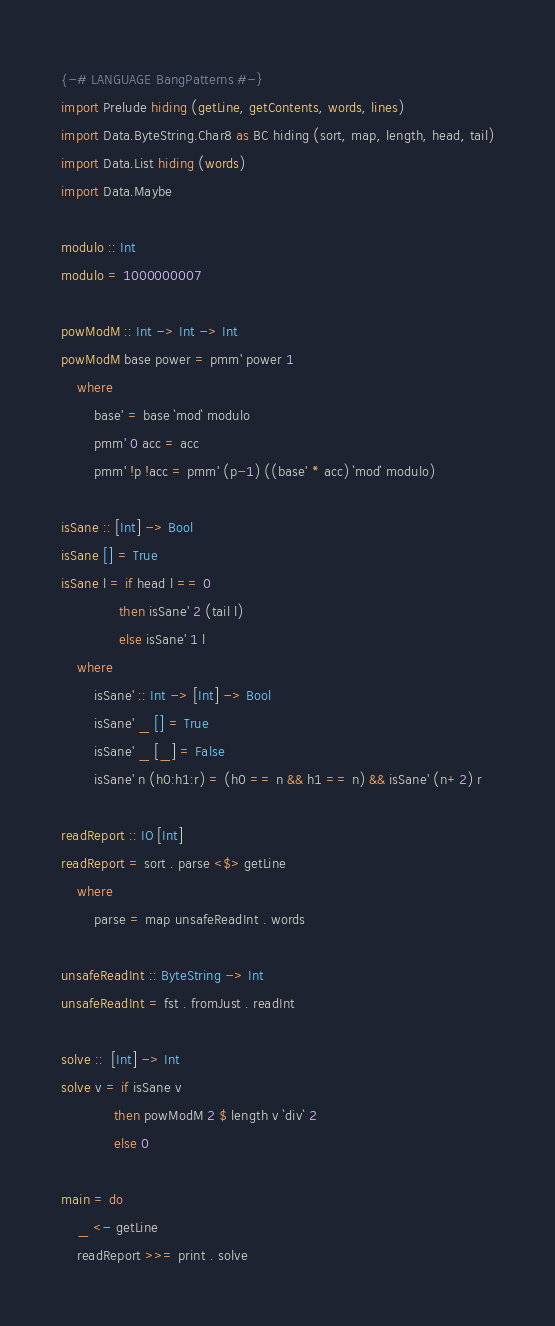<code> <loc_0><loc_0><loc_500><loc_500><_Haskell_>{-# LANGUAGE BangPatterns #-}
import Prelude hiding (getLine, getContents, words, lines)
import Data.ByteString.Char8 as BC hiding (sort, map, length, head, tail)
import Data.List hiding (words)
import Data.Maybe

modulo :: Int
modulo = 1000000007

powModM :: Int -> Int -> Int
powModM base power = pmm' power 1
    where
        base' = base `mod` modulo
        pmm' 0 acc = acc
        pmm' !p !acc = pmm' (p-1) ((base' * acc) `mod` modulo)

isSane :: [Int] -> Bool
isSane [] = True
isSane l = if head l == 0
              then isSane' 2 (tail l)
              else isSane' 1 l
    where
        isSane' :: Int -> [Int] -> Bool
        isSane' _ [] = True
        isSane' _ [_] = False
        isSane' n (h0:h1:r) = (h0 == n && h1 == n) && isSane' (n+2) r
 
readReport :: IO [Int]
readReport = sort . parse <$> getLine
    where
        parse = map unsafeReadInt . words

unsafeReadInt :: ByteString -> Int
unsafeReadInt = fst . fromJust . readInt

solve ::  [Int] -> Int
solve v = if isSane v
             then powModM 2 $ length v `div` 2
             else 0

main = do
    _ <- getLine
    readReport >>= print . solve</code> 